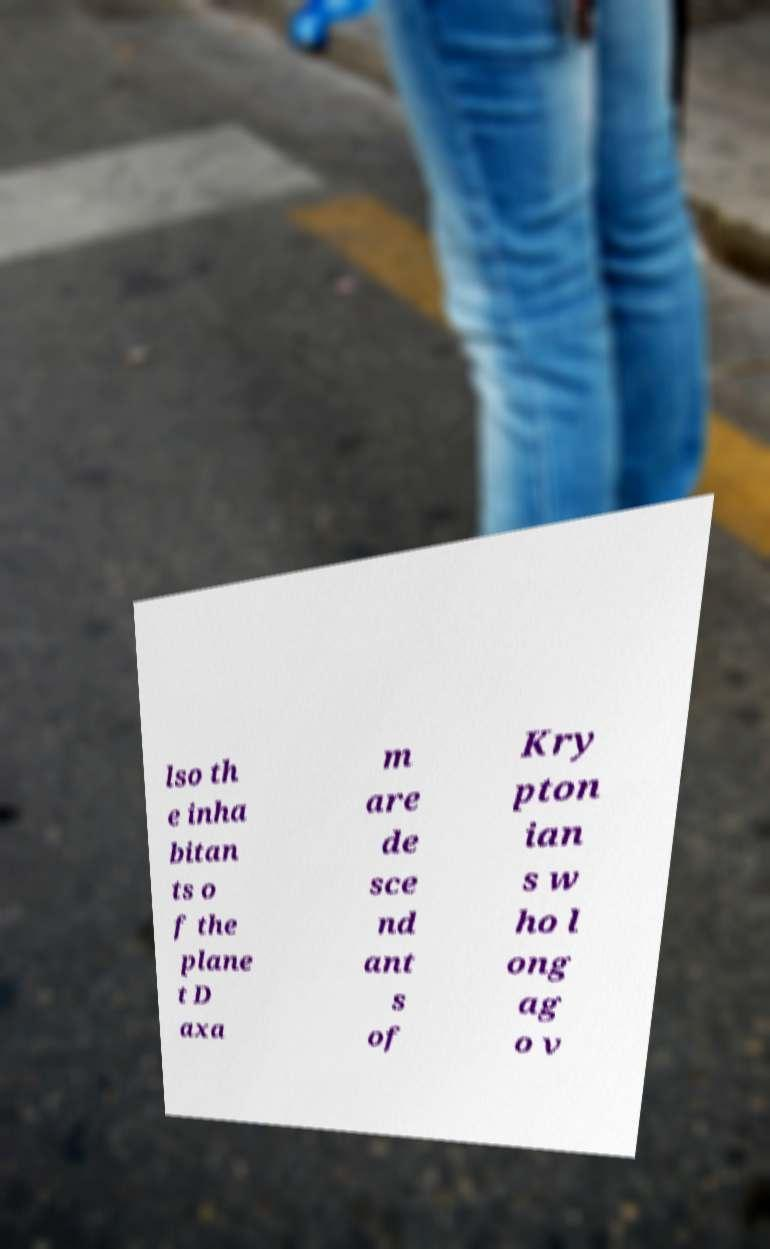I need the written content from this picture converted into text. Can you do that? lso th e inha bitan ts o f the plane t D axa m are de sce nd ant s of Kry pton ian s w ho l ong ag o v 